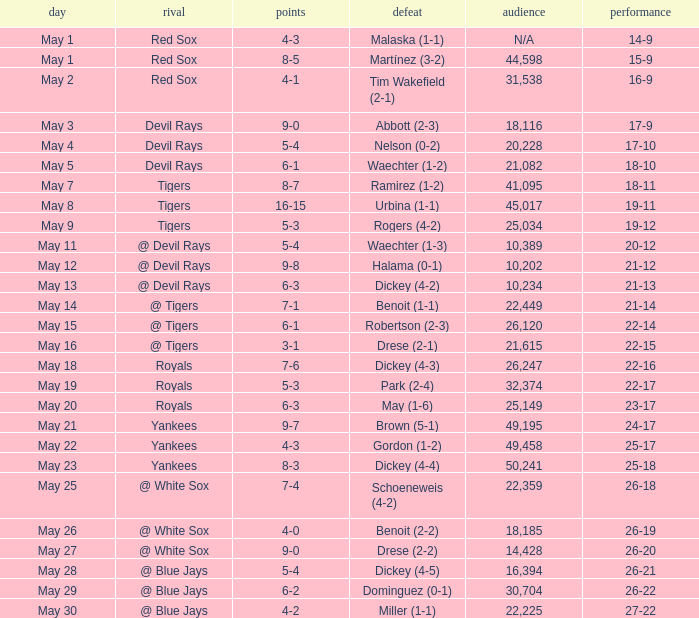What was the final score of the game where drese (2-2) lost? 9-0. 